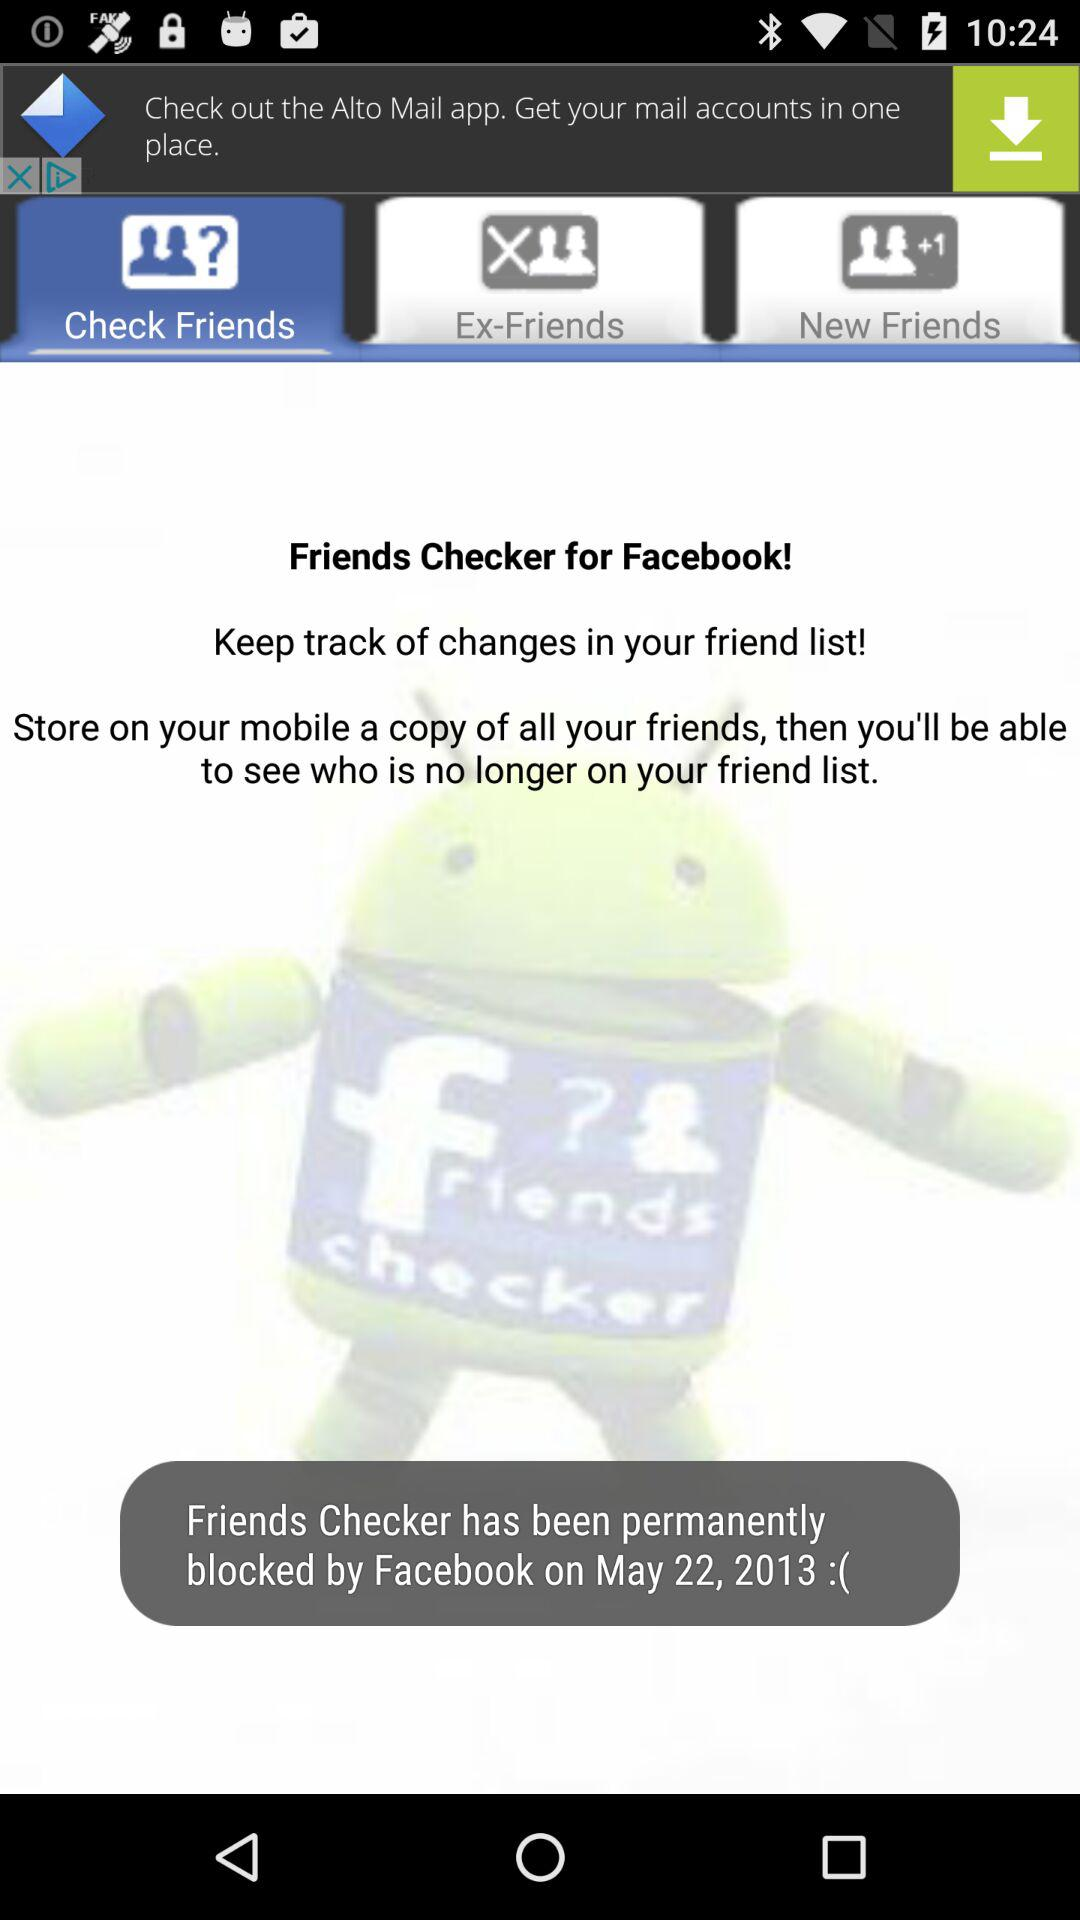When was the friends checker blocked by Facebook? The friends checker was blocked by Facebook on May 22, 2013. 